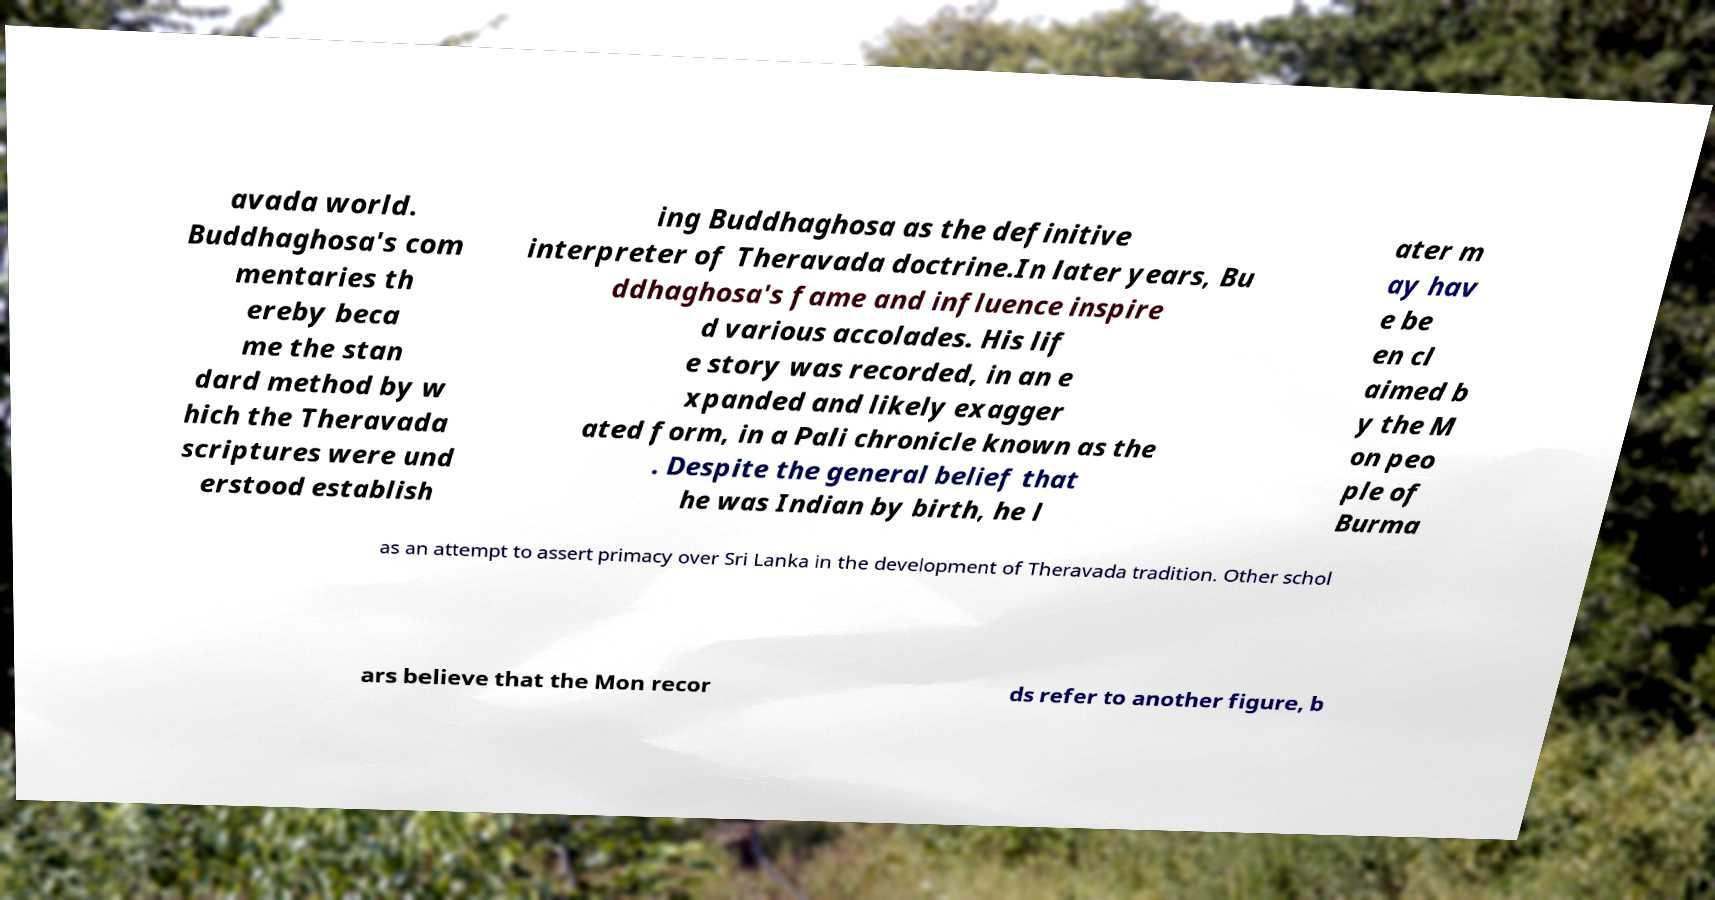Could you assist in decoding the text presented in this image and type it out clearly? avada world. Buddhaghosa's com mentaries th ereby beca me the stan dard method by w hich the Theravada scriptures were und erstood establish ing Buddhaghosa as the definitive interpreter of Theravada doctrine.In later years, Bu ddhaghosa's fame and influence inspire d various accolades. His lif e story was recorded, in an e xpanded and likely exagger ated form, in a Pali chronicle known as the . Despite the general belief that he was Indian by birth, he l ater m ay hav e be en cl aimed b y the M on peo ple of Burma as an attempt to assert primacy over Sri Lanka in the development of Theravada tradition. Other schol ars believe that the Mon recor ds refer to another figure, b 